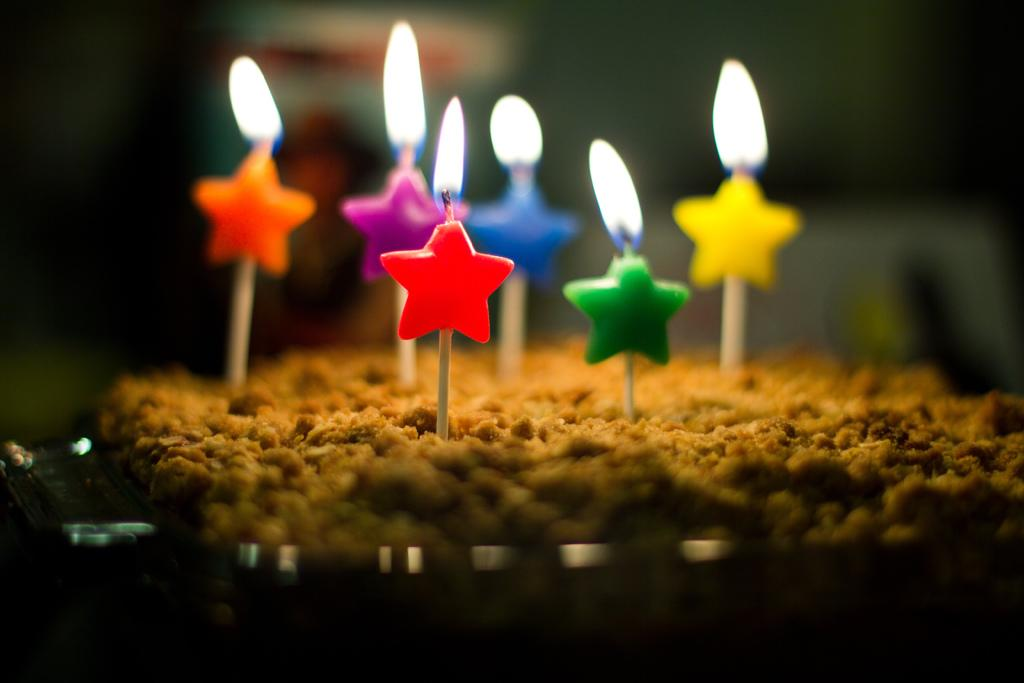What is the main subject of the image? The main subject of the image is food. What is placed on top of the food? There are candle sticks on the food. Can you describe the background of the image? The background of the image is blurry. What type of fruit is being used to support the clock in the image? There is no fruit or clock present in the image. 